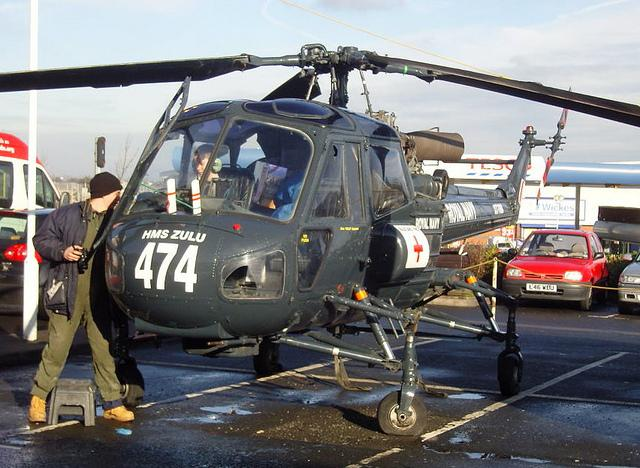What kind of chopper is this?

Choices:
A) cargo
B) attack
C) medical
D) law enforcement medical 